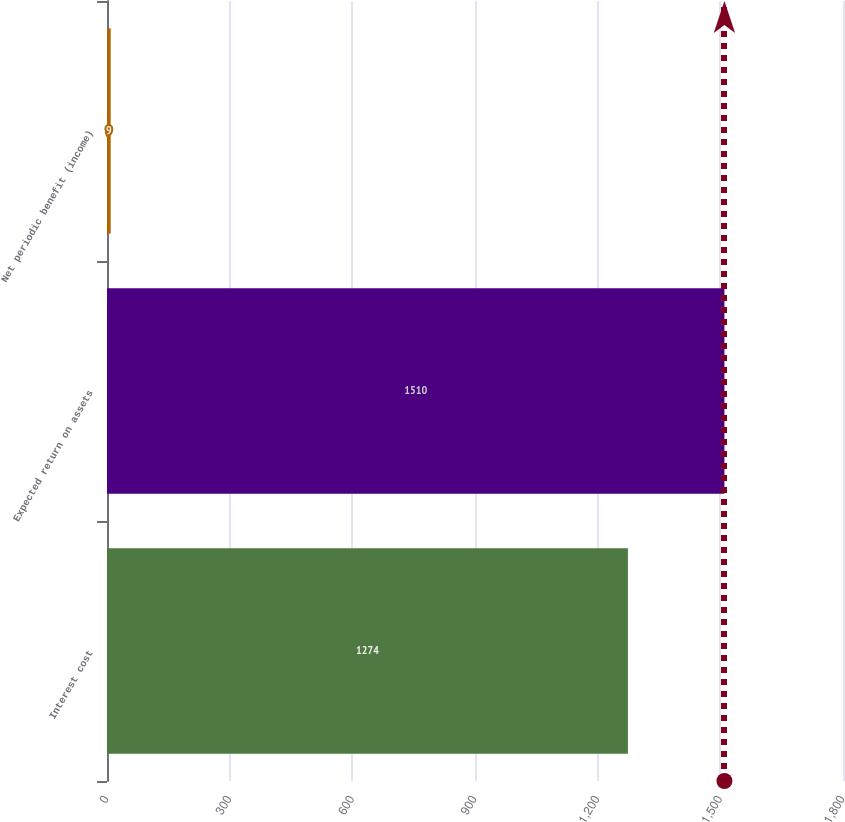<chart> <loc_0><loc_0><loc_500><loc_500><bar_chart><fcel>Interest cost<fcel>Expected return on assets<fcel>Net periodic benefit (income)<nl><fcel>1274<fcel>1510<fcel>9<nl></chart> 